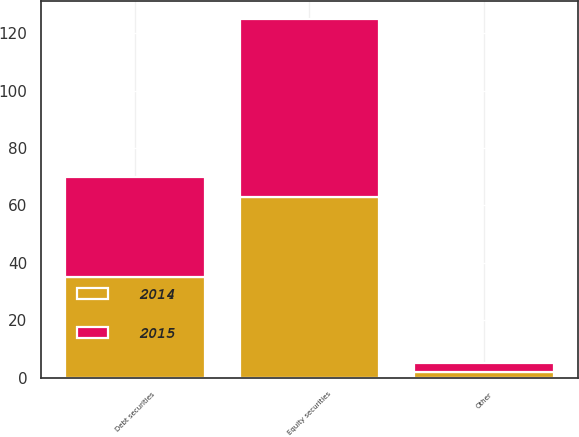Convert chart. <chart><loc_0><loc_0><loc_500><loc_500><stacked_bar_chart><ecel><fcel>Equity securities<fcel>Debt securities<fcel>Other<nl><fcel>2015<fcel>62<fcel>35<fcel>3<nl><fcel>2014<fcel>63<fcel>35<fcel>2<nl></chart> 